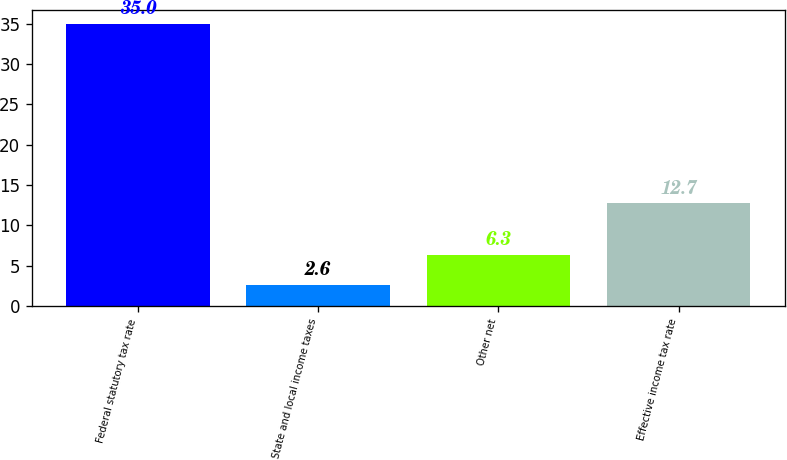Convert chart to OTSL. <chart><loc_0><loc_0><loc_500><loc_500><bar_chart><fcel>Federal statutory tax rate<fcel>State and local income taxes<fcel>Other net<fcel>Effective income tax rate<nl><fcel>35<fcel>2.6<fcel>6.3<fcel>12.7<nl></chart> 